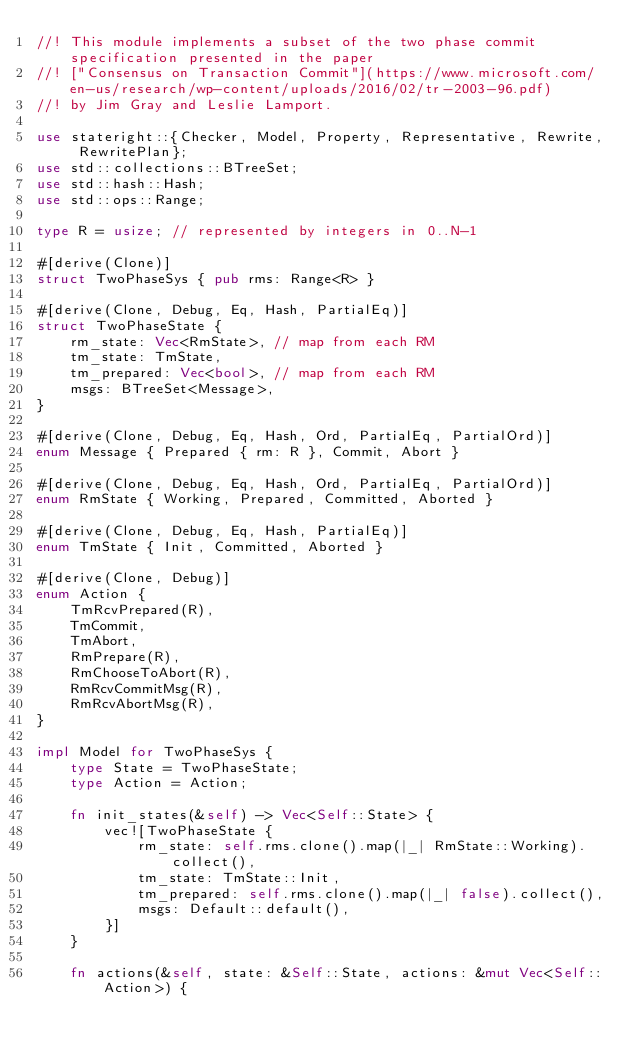<code> <loc_0><loc_0><loc_500><loc_500><_Rust_>//! This module implements a subset of the two phase commit specification presented in the paper
//! ["Consensus on Transaction Commit"](https://www.microsoft.com/en-us/research/wp-content/uploads/2016/02/tr-2003-96.pdf)
//! by Jim Gray and Leslie Lamport.

use stateright::{Checker, Model, Property, Representative, Rewrite, RewritePlan};
use std::collections::BTreeSet;
use std::hash::Hash;
use std::ops::Range;

type R = usize; // represented by integers in 0..N-1

#[derive(Clone)]
struct TwoPhaseSys { pub rms: Range<R> }

#[derive(Clone, Debug, Eq, Hash, PartialEq)]
struct TwoPhaseState {
    rm_state: Vec<RmState>, // map from each RM
    tm_state: TmState,
    tm_prepared: Vec<bool>, // map from each RM
    msgs: BTreeSet<Message>,
}

#[derive(Clone, Debug, Eq, Hash, Ord, PartialEq, PartialOrd)]
enum Message { Prepared { rm: R }, Commit, Abort }

#[derive(Clone, Debug, Eq, Hash, Ord, PartialEq, PartialOrd)]
enum RmState { Working, Prepared, Committed, Aborted }

#[derive(Clone, Debug, Eq, Hash, PartialEq)]
enum TmState { Init, Committed, Aborted }

#[derive(Clone, Debug)]
enum Action {
    TmRcvPrepared(R),
    TmCommit,
    TmAbort,
    RmPrepare(R),
    RmChooseToAbort(R),
    RmRcvCommitMsg(R),
    RmRcvAbortMsg(R),
}

impl Model for TwoPhaseSys {
    type State = TwoPhaseState;
    type Action = Action;

    fn init_states(&self) -> Vec<Self::State> {
        vec![TwoPhaseState {
            rm_state: self.rms.clone().map(|_| RmState::Working).collect(),
            tm_state: TmState::Init,
            tm_prepared: self.rms.clone().map(|_| false).collect(),
            msgs: Default::default(),
        }]
    }

    fn actions(&self, state: &Self::State, actions: &mut Vec<Self::Action>) {</code> 